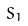<formula> <loc_0><loc_0><loc_500><loc_500>S _ { 1 }</formula> 